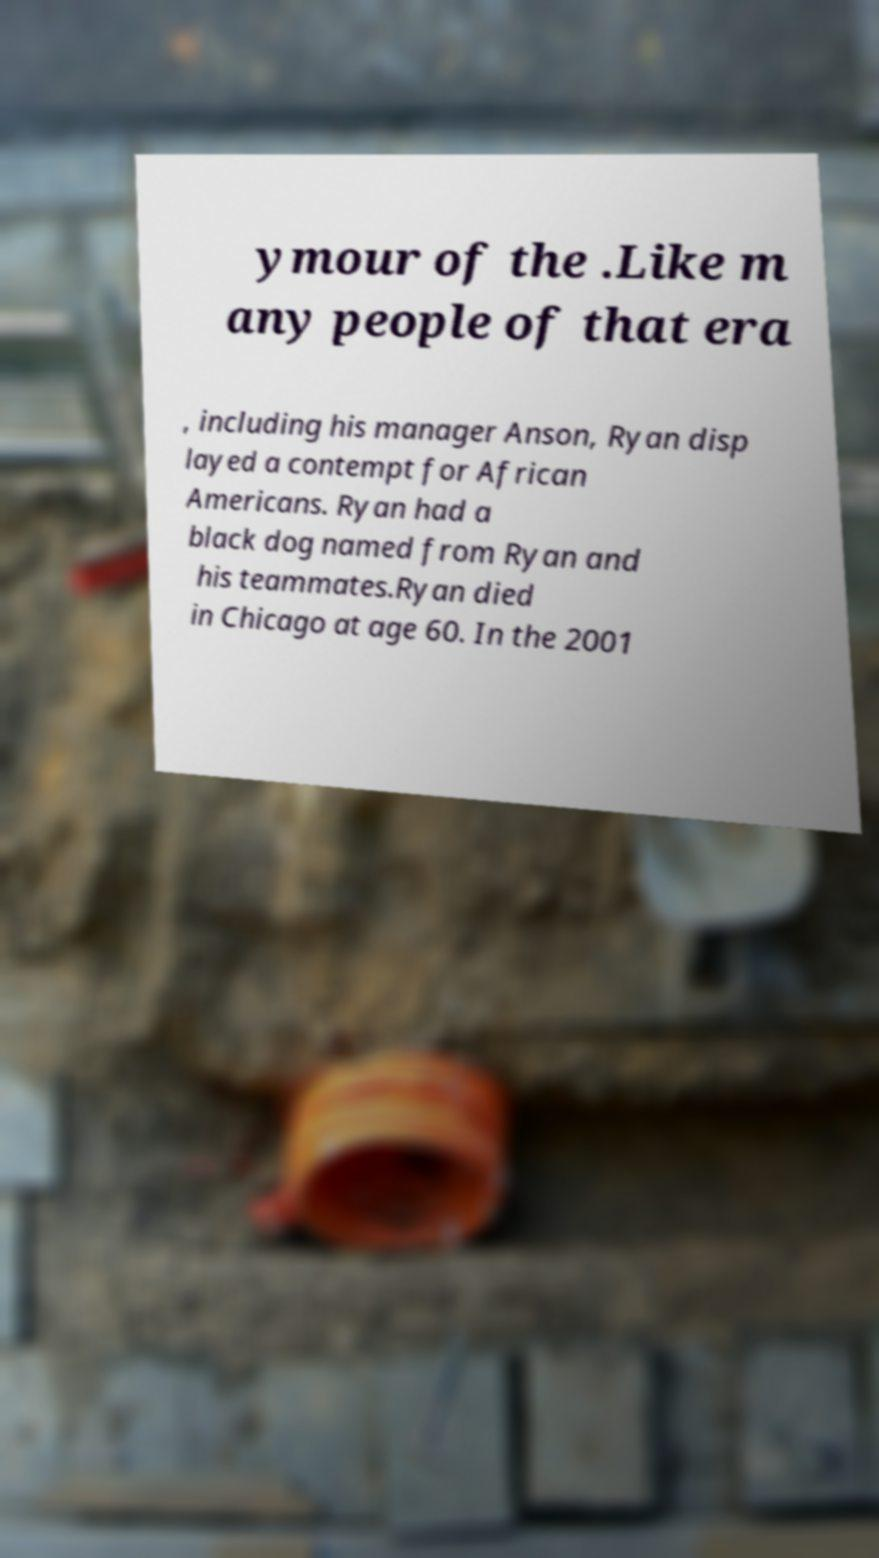Please read and relay the text visible in this image. What does it say? ymour of the .Like m any people of that era , including his manager Anson, Ryan disp layed a contempt for African Americans. Ryan had a black dog named from Ryan and his teammates.Ryan died in Chicago at age 60. In the 2001 